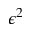<formula> <loc_0><loc_0><loc_500><loc_500>\epsilon ^ { 2 }</formula> 